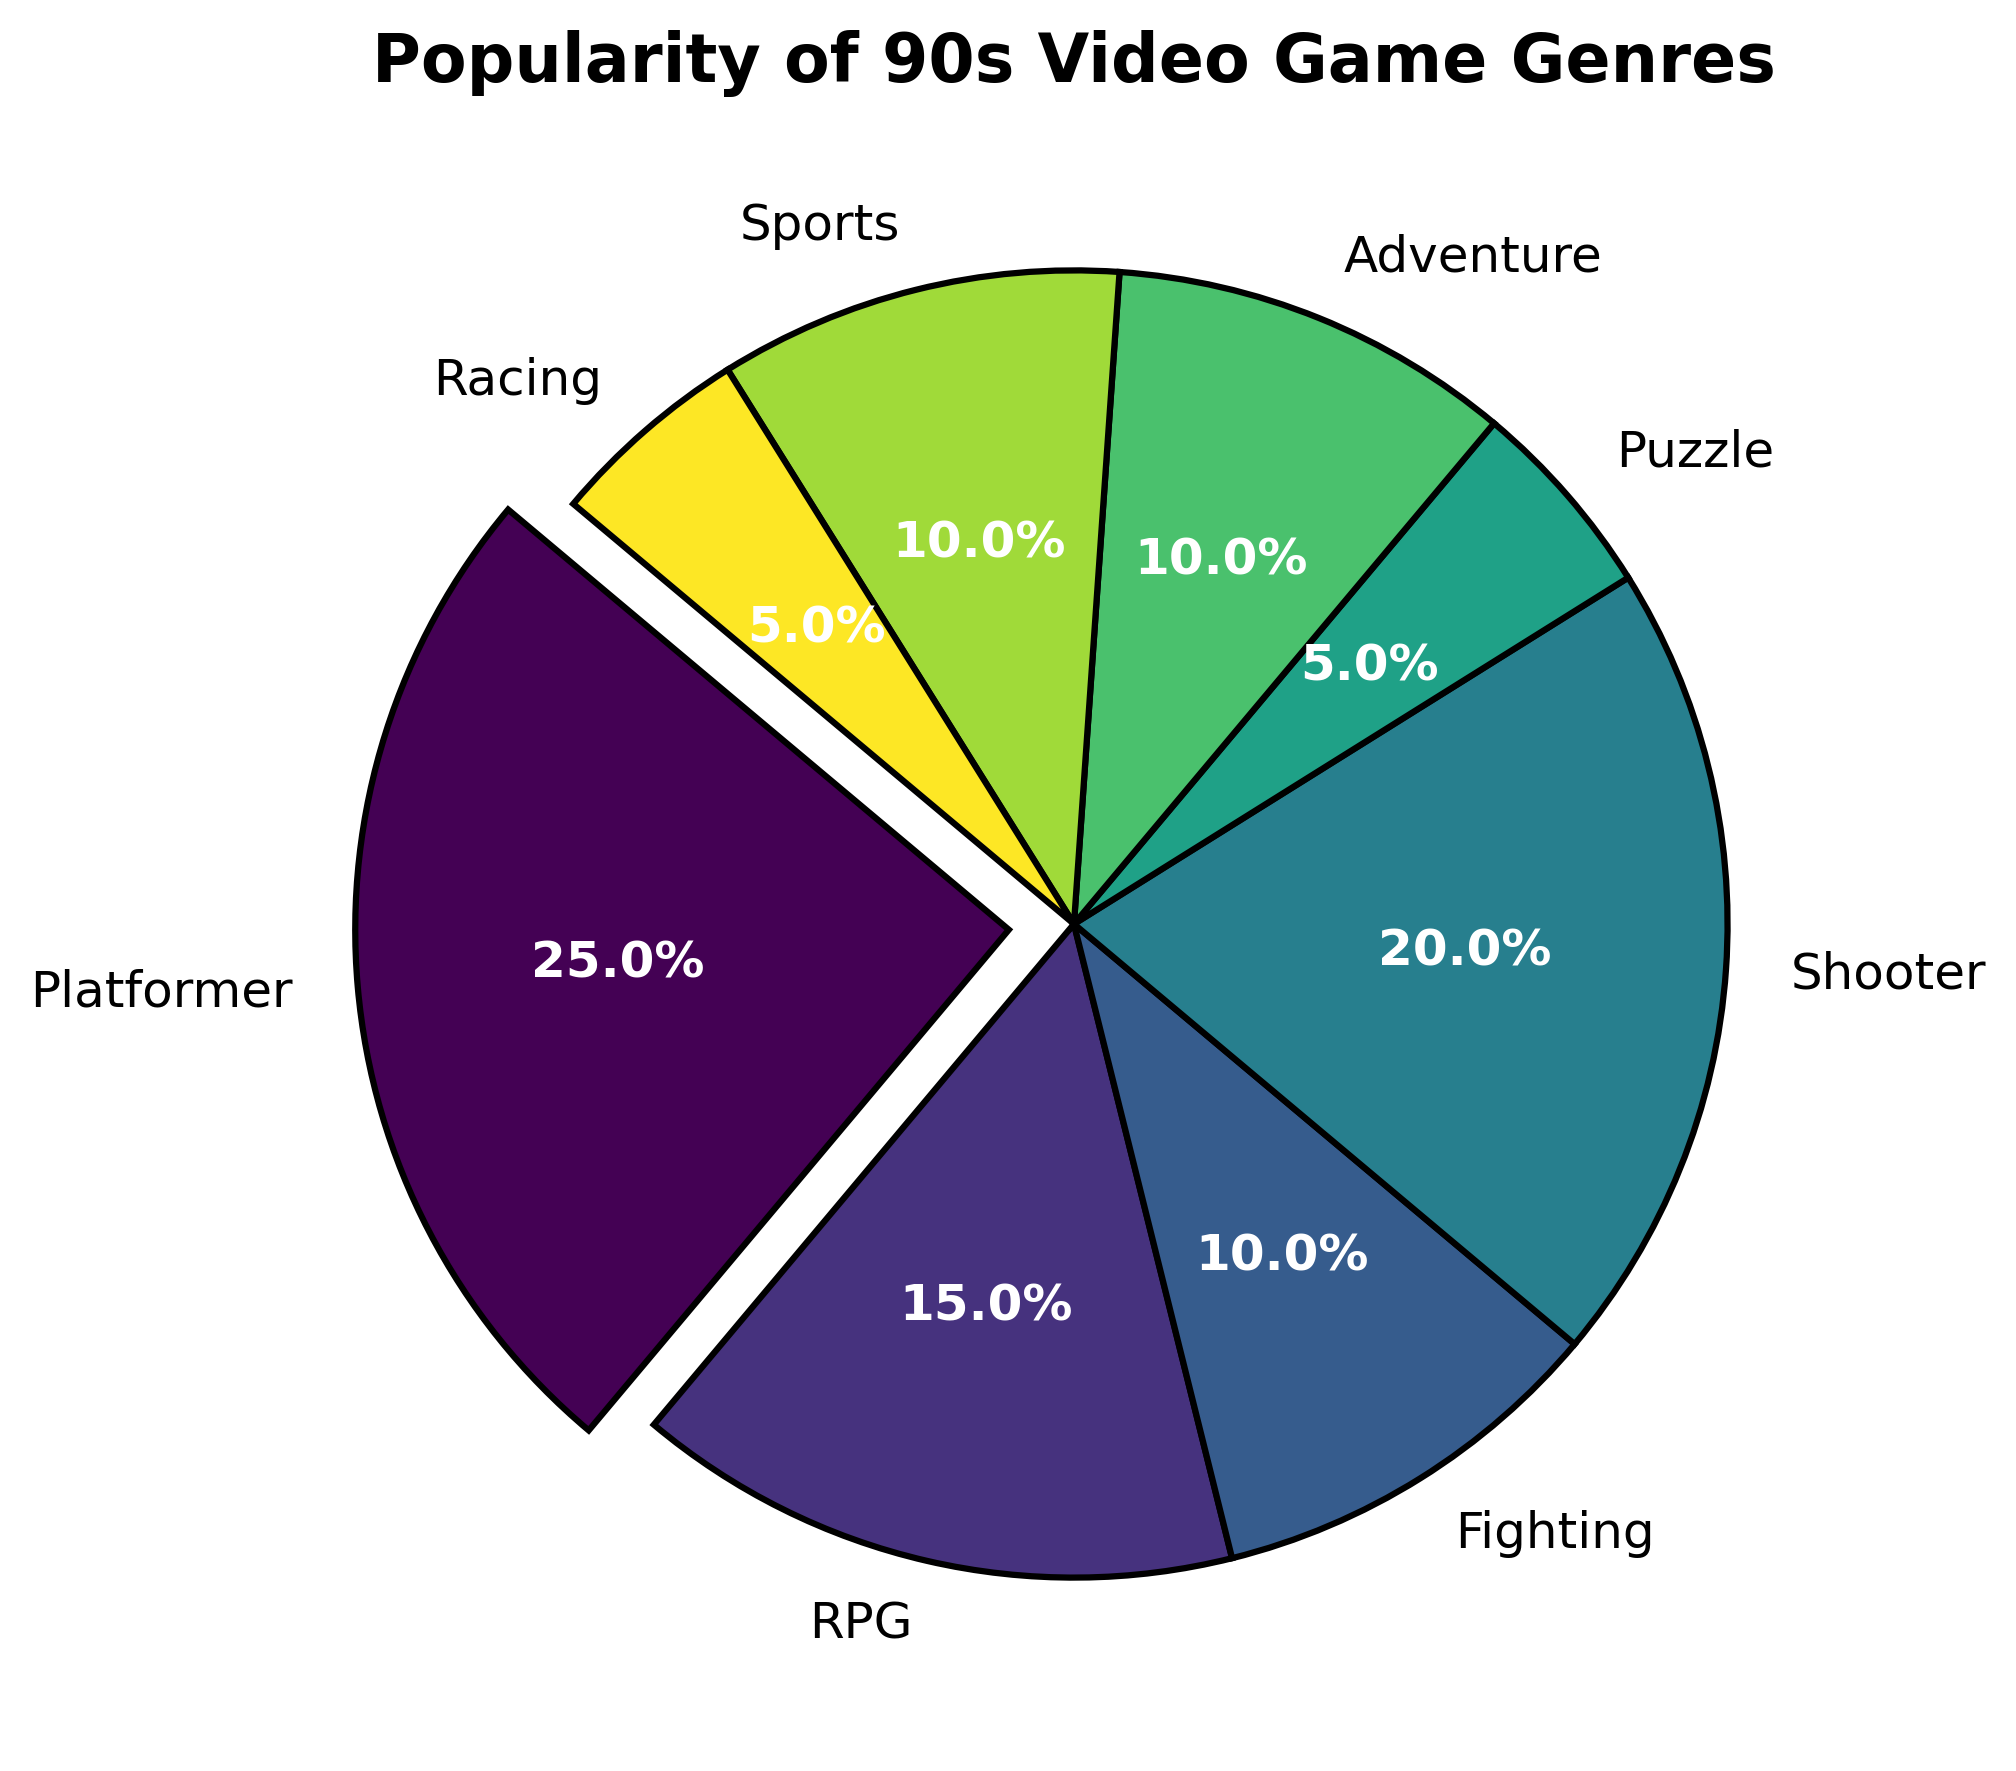What is the most popular genre of 90s video games? The slice with the largest percentage represents the most popular genre. From the pie chart, the Platformer genre has the largest slice, making up 25% of the total.
Answer: Platformer Which genres hold the same popularity percentage? To find genres with equal popularity, look for slices that represent the same size. Both Fighting, Adventure, and Sports genres each have a 10% slice.
Answer: Fighting, Adventure, Sports How much more popular is the Platformer genre compared to the Sports genre? First find the percentage for both genres. Platformer has 25% and Sports has 10%. The difference is calculated as 25% - 10% = 15%.
Answer: 15% Which genre has the smallest representation in the pie chart? The smallest slice represents the least popular genre. Both Puzzle and Racing have the smallest slices with 5% each.
Answer: Puzzle, Racing What is the combined popularity percentage of Shooter and RPG genres? Add the percentages of the Shooter (20%) and RPG (15%) genres. 20% + 15% = 35%.
Answer: 35% Is the Adventure genre more or less popular than the Shooter genre? Compare the percentages of Adventure (10%) and Shooter (20%). Adventure is less popular than Shooter.
Answer: Less Which genre's slice in the pie chart is exploded? The exploded slice stands out from the rest. The Platformer genre's slice is exploded in the pie chart.
Answer: Platformer What percentage of the pie chart is made up of Platformer, Fighting, and Racing genres combined? Add the percentages of Platformer (25%), Fighting (10%), and Racing (5%) genres. 25% + 10% + 5% = 40%.
Answer: 40% If the Shooter genre were to gain in popularity by 5%, what would be its new percentage? Add 5% to the current Shooter genre percentage (20%). 20% + 5% = 25%.
Answer: 25% Which color is used for the Adventure genre slice? By observing the pie chart legend or directly looking at the color of the Adventure slice, it is possible to determine the color used.
Answer: Answer will vary depending on visualization 